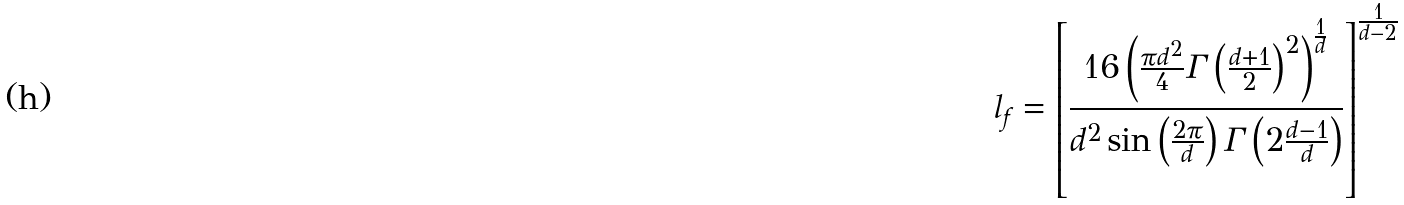Convert formula to latex. <formula><loc_0><loc_0><loc_500><loc_500>l _ { f } = \left [ \frac { 1 6 \left ( \frac { \pi d ^ { 2 } } { 4 } \Gamma \left ( \frac { d + 1 } { 2 } \right ) ^ { 2 } \right ) ^ { \frac { 1 } { d } } } { d ^ { 2 } \sin \left ( \frac { 2 \pi } { d } \right ) \Gamma \left ( 2 \frac { d - 1 } { d } \right ) } \right ] ^ { \frac { 1 } { d - 2 } }</formula> 